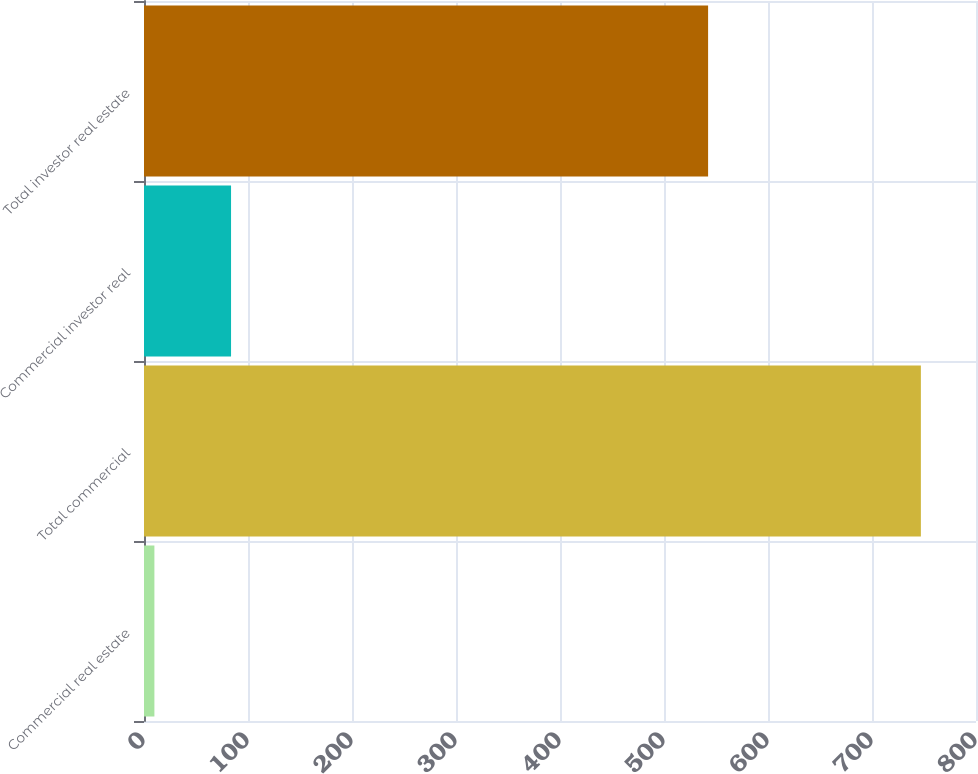<chart> <loc_0><loc_0><loc_500><loc_500><bar_chart><fcel>Commercial real estate<fcel>Total commercial<fcel>Commercial investor real<fcel>Total investor real estate<nl><fcel>10<fcel>747<fcel>83.7<fcel>542.4<nl></chart> 